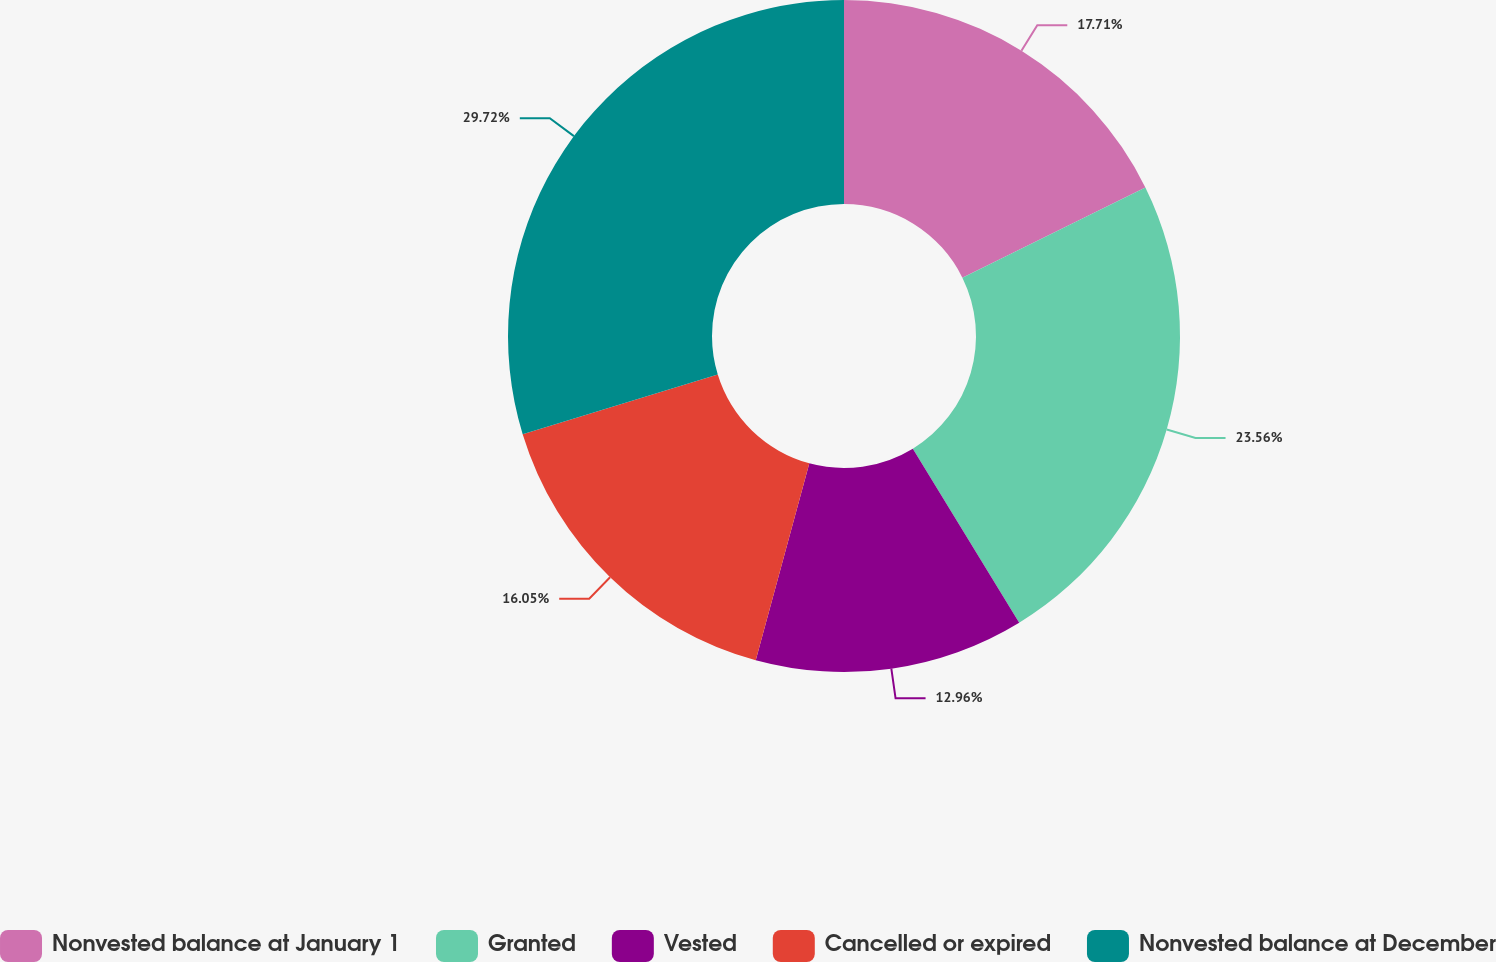<chart> <loc_0><loc_0><loc_500><loc_500><pie_chart><fcel>Nonvested balance at January 1<fcel>Granted<fcel>Vested<fcel>Cancelled or expired<fcel>Nonvested balance at December<nl><fcel>17.71%<fcel>23.56%<fcel>12.96%<fcel>16.05%<fcel>29.72%<nl></chart> 